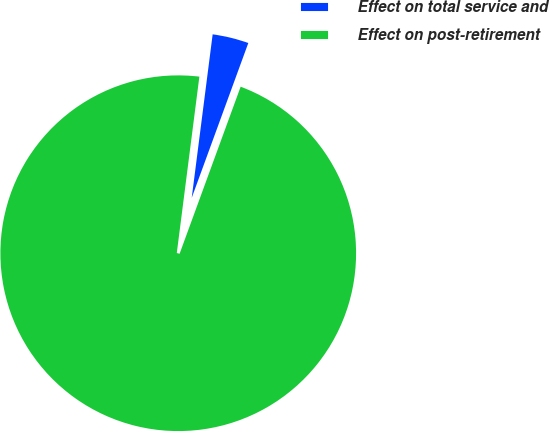Convert chart. <chart><loc_0><loc_0><loc_500><loc_500><pie_chart><fcel>Effect on total service and<fcel>Effect on post-retirement<nl><fcel>3.55%<fcel>96.45%<nl></chart> 